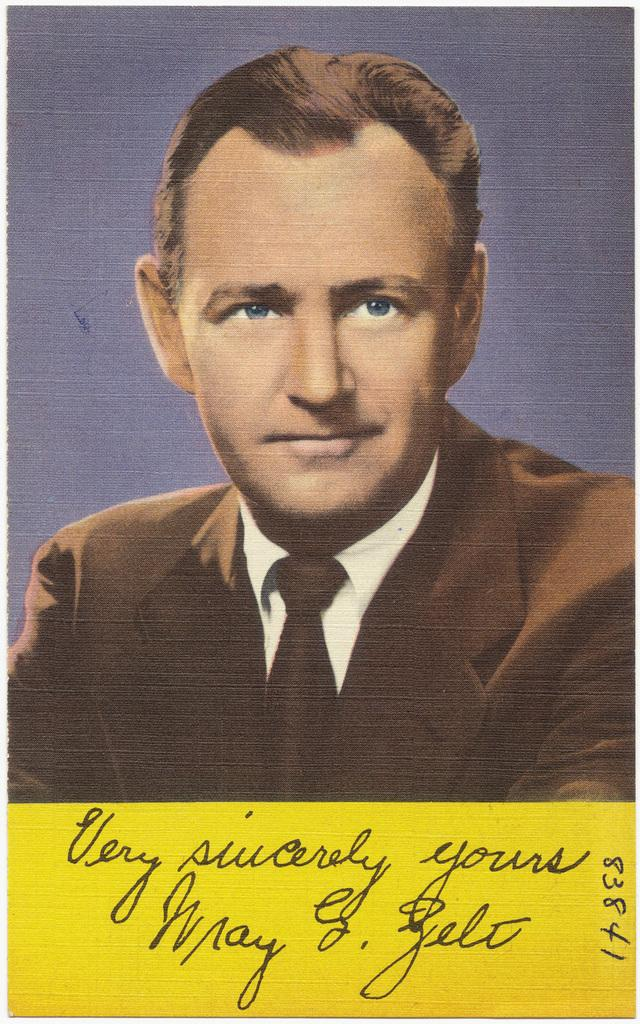What type of content is present in the image? There is art and text in the image. Can you describe the art in the image? Unfortunately, the description of the art is not provided in the facts. What does the text in the image say? The content of the text is not mentioned in the facts. How many chickens are depicted in the image? There are no chickens present in the image. What size are the shoes in the image? There are no shoes present in the image. 